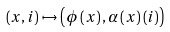Convert formula to latex. <formula><loc_0><loc_0><loc_500><loc_500>\left ( x , i \right ) \mapsto \left ( \phi \left ( x \right ) , \alpha \left ( x \right ) \left ( i \right ) \right )</formula> 